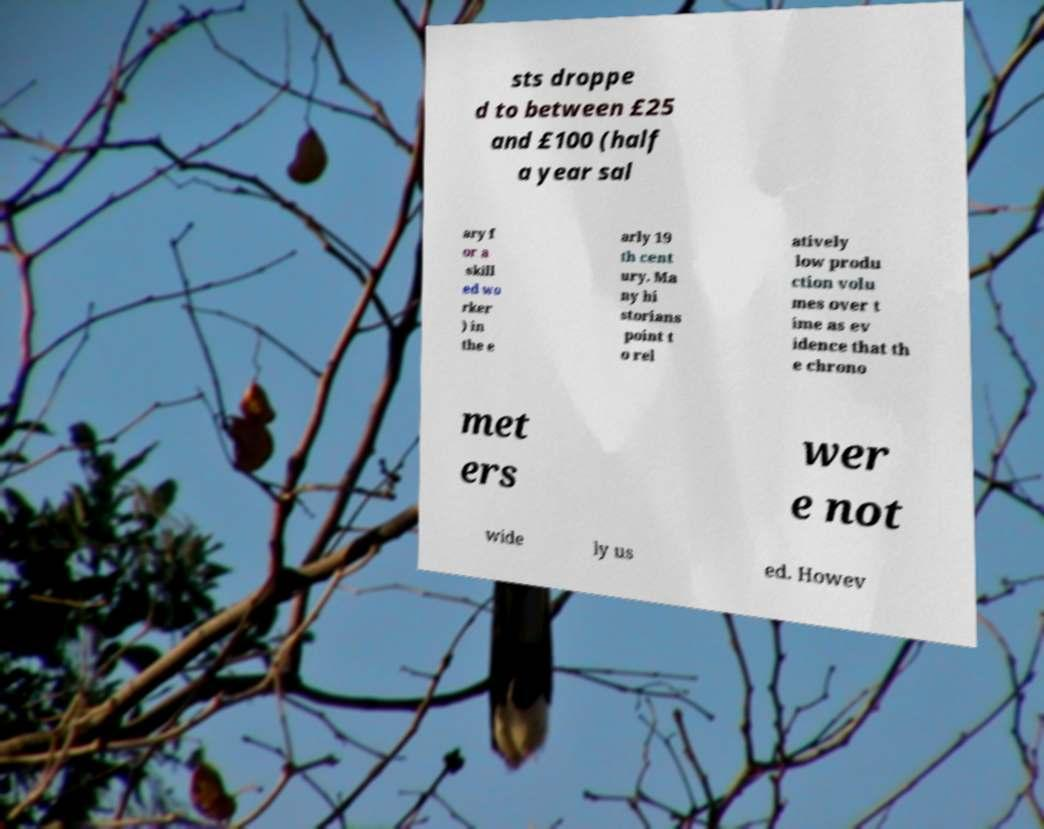Please identify and transcribe the text found in this image. sts droppe d to between £25 and £100 (half a year sal ary f or a skill ed wo rker ) in the e arly 19 th cent ury. Ma ny hi storians point t o rel atively low produ ction volu mes over t ime as ev idence that th e chrono met ers wer e not wide ly us ed. Howev 